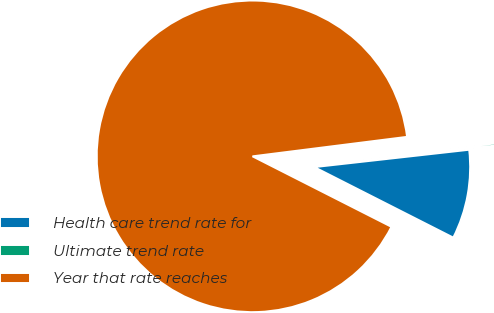Convert chart to OTSL. <chart><loc_0><loc_0><loc_500><loc_500><pie_chart><fcel>Health care trend rate for<fcel>Ultimate trend rate<fcel>Year that rate reaches<nl><fcel>9.25%<fcel>0.22%<fcel>90.52%<nl></chart> 